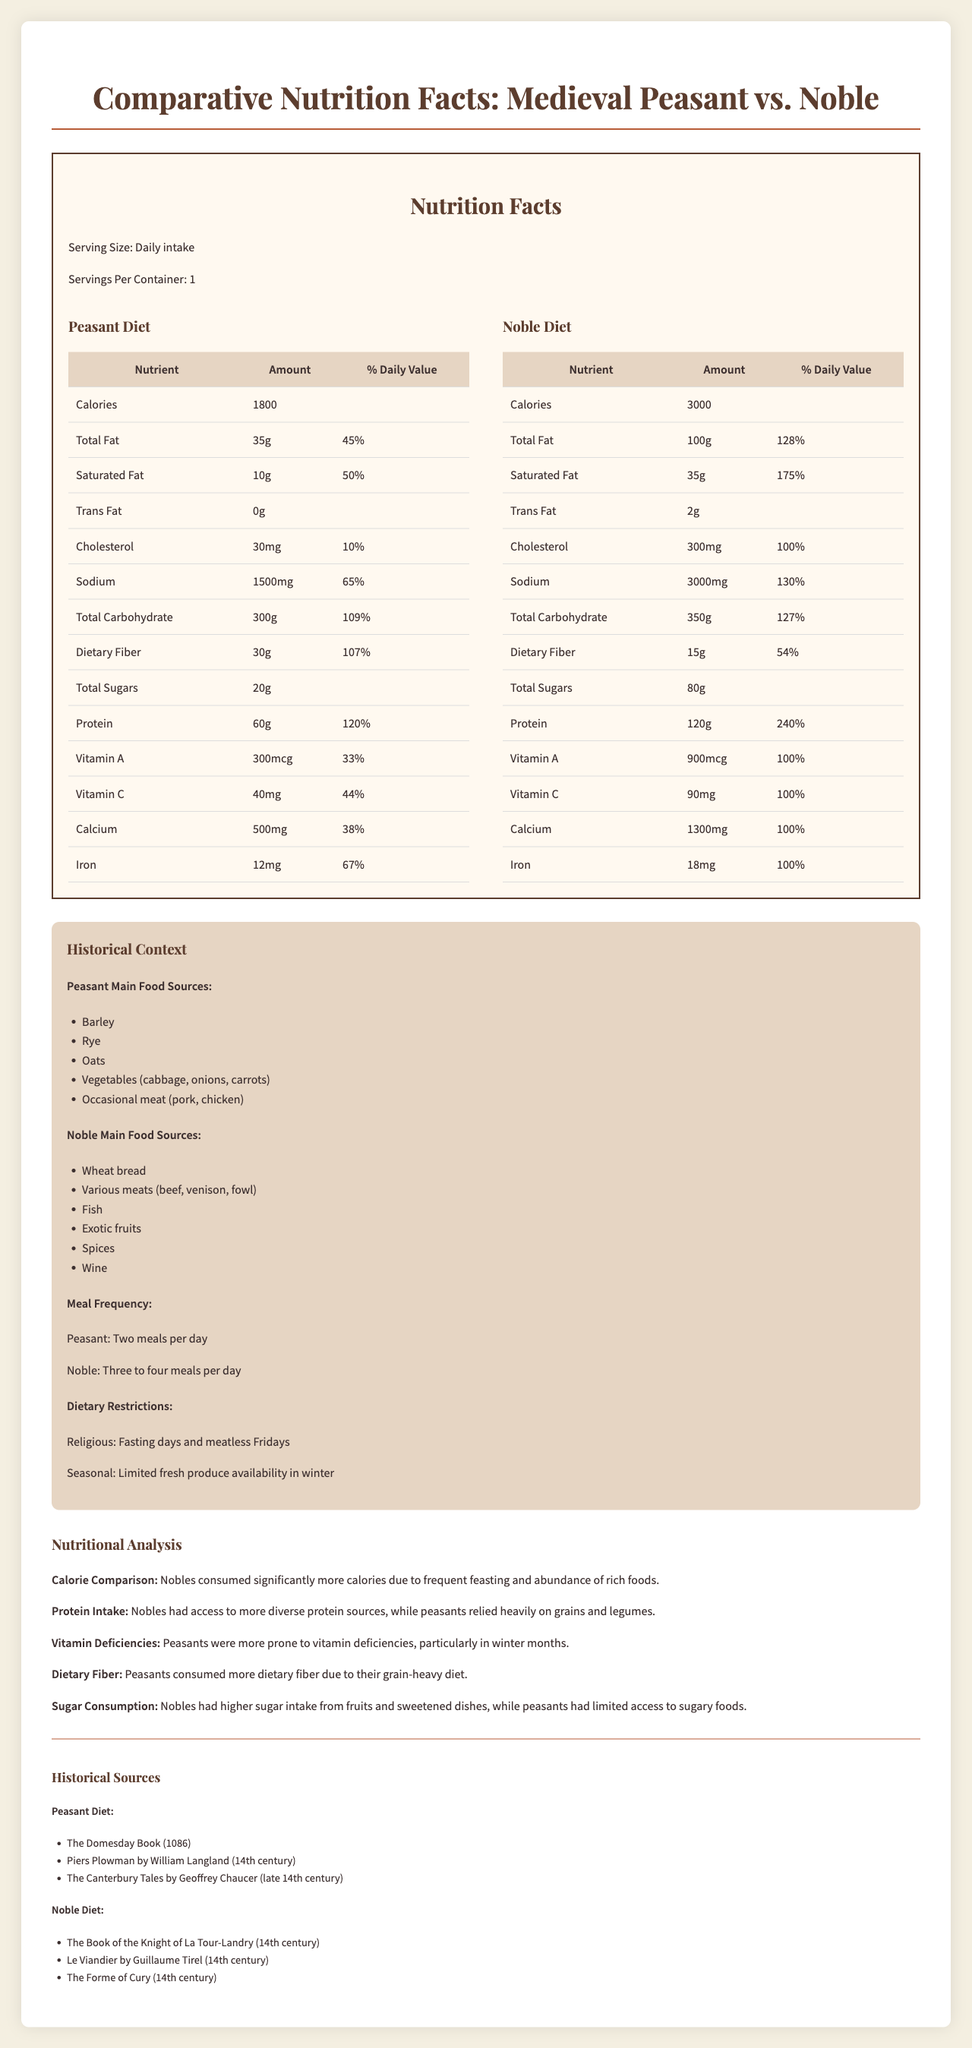What is the serving size stated in the document? The serving size is explicitly listed as "Daily intake" in the document.
Answer: Daily intake How many calories does a medieval peasant typically consume in a day? The calories for a peasant's diet are displayed as 1800 under the Peasant Diet section.
Answer: 1800 Which diet includes more total fat? The Noble Diet lists 100g of total fat, whereas the Peasant Diet lists 35g.
Answer: Noble Diet Which vitamin has a higher daily value percentage in the noble diet compared to the peasant diet? A. Vitamin A B. Vitamin C C. Calcium The noble diet provides 100% daily value of Vitamin A versus 33% for the peasant diet.
Answer: A How many grams of dietary fiber do peasants consume daily? The dietary fiber amount listed under the Peasant Diet is 30g.
Answer: 30g What are the main sources of food for a medieval peasant? The main food sources for the medieval peasant are listed in the Historical Context section.
Answer: Barley, Rye, Oats, Vegetables (cabbage, onions, carrots), Occasional meat (pork, chicken) What percentage of the daily value for iron does a peasant consume compared to a noble? A. 67% B. 100% C. 50% The Peasant Diet includes a 67% daily value for iron, while the Noble Diet includes 100%.
Answer: A Does the noble diet include any trans fat? The document lists 2g of trans fat in the Noble Diet.
Answer: Yes Which group is likely to have had higher sugar intake? Nobles consumed more sugar (80g) compared to peasants (20g), likely due to access to exotic fruits and sweetened dishes.
Answer: Nobles Did peasants consume more or less dietary fiber than nobles? Peasants consumed 30g of dietary fiber as opposed to nobles who consumed 15g.
Answer: More Summarize the nutritional differences between medieval peasants and nobles. The document compares the nutritional intake of medieval peasants and nobles, highlighting that nobles had a richer diet in terms of calories and various nutrients, while peasants consumed more dietary fiber.
Answer: Nobles consumed more calories, total fat, saturated fat, cholesterol, sodium, total carbohydrates, total sugars, protein, vitamin A, vitamin C, calcium, and iron compared to peasants. Peasants consumed more dietary fiber. Can we determine the exact health impact of these diets on medieval peasants and nobles from the document? The document provides nutritional information but does not offer detailed health impact analysis for the diets of medieval peasants and nobles.
Answer: Not enough information 